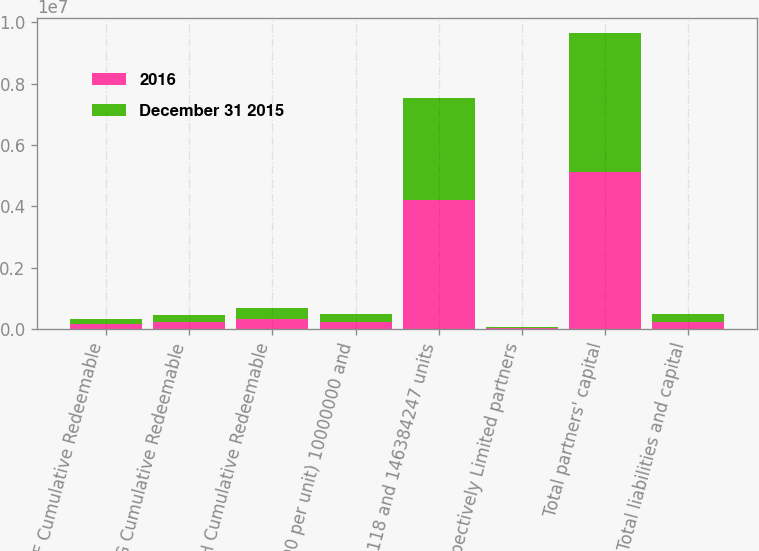<chart> <loc_0><loc_0><loc_500><loc_500><stacked_bar_chart><ecel><fcel>Series F Cumulative Redeemable<fcel>Series G Cumulative Redeemable<fcel>Series H Cumulative Redeemable<fcel>(2500 per unit) 10000000 and<fcel>159019118 and 146384247 units<fcel>respectively Limited partners<fcel>Total partners' capital<fcel>Total liabilities and capital<nl><fcel>2016<fcel>176191<fcel>241468<fcel>353290<fcel>242012<fcel>4.21866e+06<fcel>34698<fcel>5.1257e+06<fcel>242013<nl><fcel>December 31 2015<fcel>176191<fcel>241468<fcel>353290<fcel>242014<fcel>3.30522e+06<fcel>33986<fcel>4.52838e+06<fcel>242013<nl></chart> 